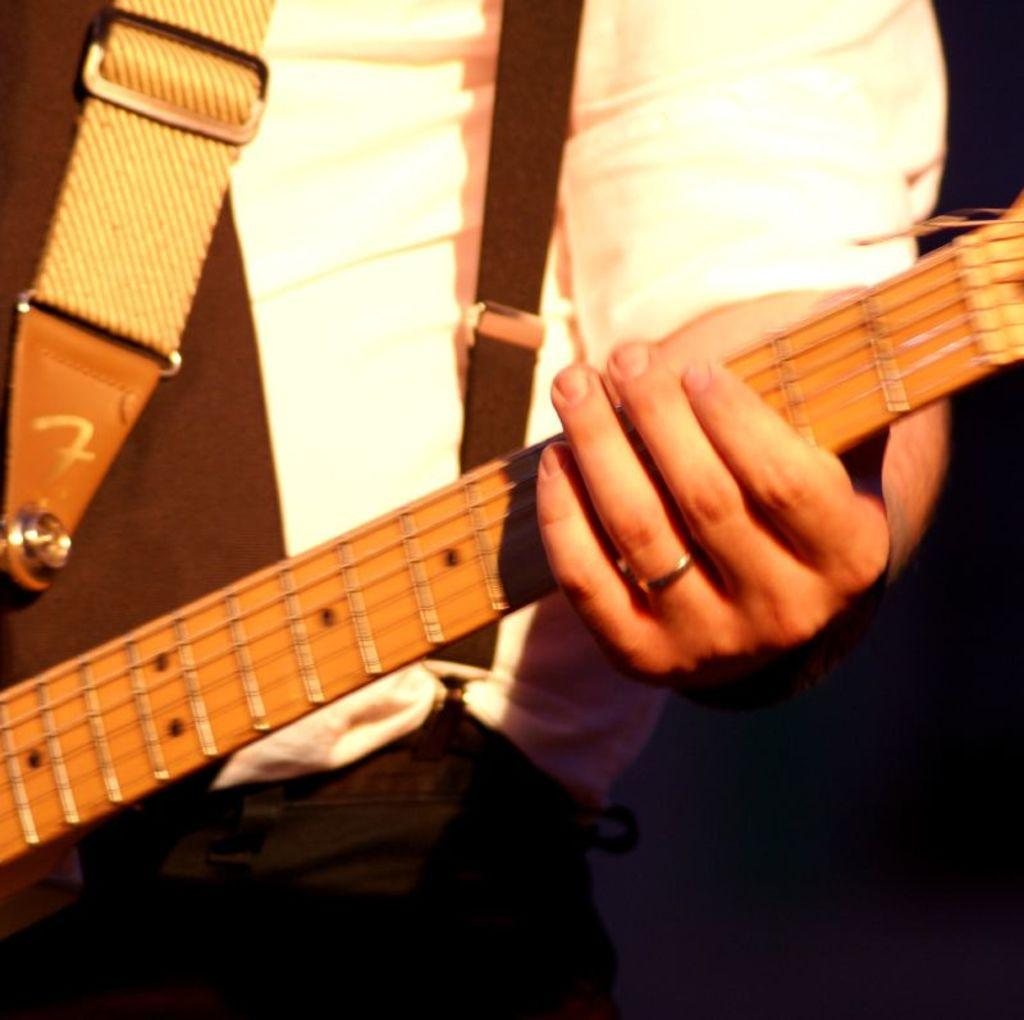What is the person in the image doing? The person is playing a guitar. What is the person wearing in the image? The person is wearing a white shirt and a black tie. How is the person holding the guitar? The person is holding the guitar in their hand. Can you describe any jewelry the person is wearing? The person has a ring on their ring finger. What statement does the person make while playing the guitar in the image? There is no indication in the image that the person is making a statement while playing the guitar. 